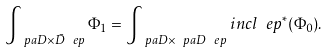Convert formula to latex. <formula><loc_0><loc_0><loc_500><loc_500>\int _ { \ p a D \times \bar { D } _ { \ } e p } \Phi _ { 1 } = \int _ { \ p a D \times \ p a D _ { \ } e p } i n c l _ { \ } e p ^ { * } ( \Phi _ { 0 } ) .</formula> 